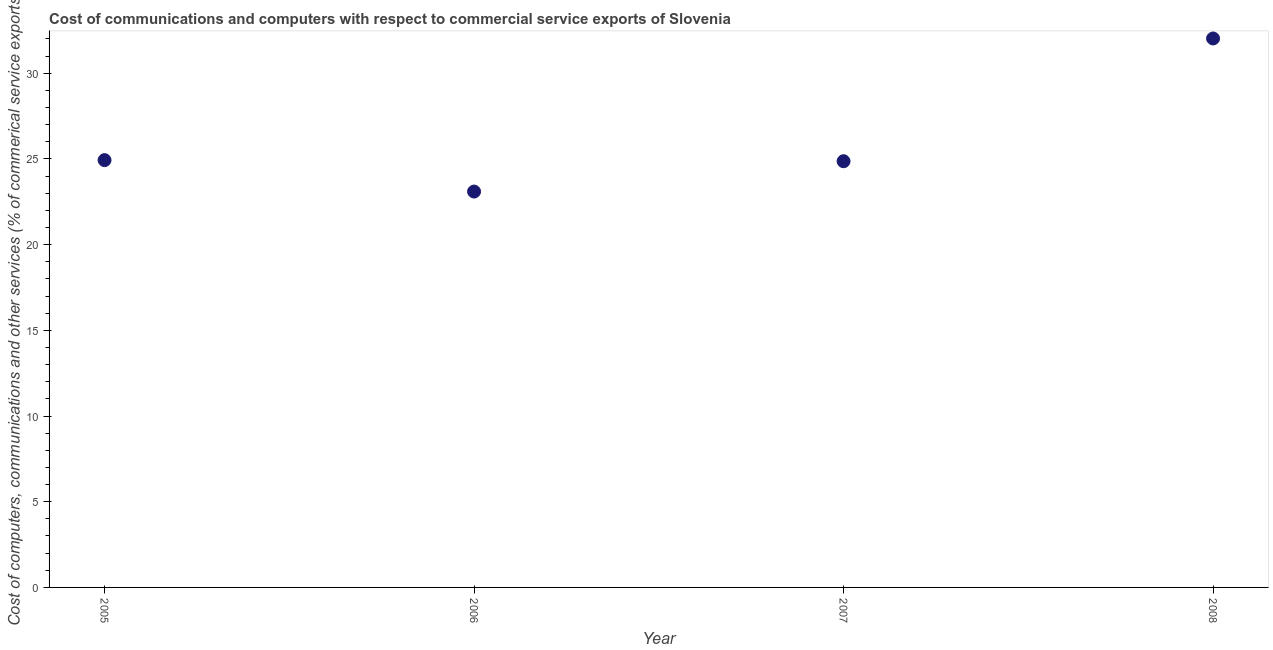What is the  computer and other services in 2006?
Keep it short and to the point. 23.09. Across all years, what is the maximum  computer and other services?
Your response must be concise. 32.02. Across all years, what is the minimum  computer and other services?
Your answer should be compact. 23.09. In which year was the cost of communications maximum?
Keep it short and to the point. 2008. What is the sum of the  computer and other services?
Ensure brevity in your answer.  104.9. What is the difference between the cost of communications in 2006 and 2007?
Give a very brief answer. -1.77. What is the average cost of communications per year?
Your answer should be compact. 26.23. What is the median cost of communications?
Ensure brevity in your answer.  24.89. Do a majority of the years between 2007 and 2008 (inclusive) have cost of communications greater than 29 %?
Keep it short and to the point. No. What is the ratio of the  computer and other services in 2006 to that in 2007?
Your answer should be very brief. 0.93. What is the difference between the highest and the second highest  computer and other services?
Make the answer very short. 7.1. What is the difference between the highest and the lowest cost of communications?
Your answer should be very brief. 8.93. Does the cost of communications monotonically increase over the years?
Offer a terse response. No. Does the graph contain any zero values?
Provide a succinct answer. No. What is the title of the graph?
Your response must be concise. Cost of communications and computers with respect to commercial service exports of Slovenia. What is the label or title of the Y-axis?
Your answer should be compact. Cost of computers, communications and other services (% of commerical service exports). What is the Cost of computers, communications and other services (% of commerical service exports) in 2005?
Offer a very short reply. 24.93. What is the Cost of computers, communications and other services (% of commerical service exports) in 2006?
Ensure brevity in your answer.  23.09. What is the Cost of computers, communications and other services (% of commerical service exports) in 2007?
Make the answer very short. 24.86. What is the Cost of computers, communications and other services (% of commerical service exports) in 2008?
Offer a terse response. 32.02. What is the difference between the Cost of computers, communications and other services (% of commerical service exports) in 2005 and 2006?
Keep it short and to the point. 1.83. What is the difference between the Cost of computers, communications and other services (% of commerical service exports) in 2005 and 2007?
Provide a succinct answer. 0.06. What is the difference between the Cost of computers, communications and other services (% of commerical service exports) in 2005 and 2008?
Your response must be concise. -7.1. What is the difference between the Cost of computers, communications and other services (% of commerical service exports) in 2006 and 2007?
Your answer should be very brief. -1.77. What is the difference between the Cost of computers, communications and other services (% of commerical service exports) in 2006 and 2008?
Your answer should be very brief. -8.93. What is the difference between the Cost of computers, communications and other services (% of commerical service exports) in 2007 and 2008?
Your answer should be very brief. -7.16. What is the ratio of the Cost of computers, communications and other services (% of commerical service exports) in 2005 to that in 2006?
Offer a very short reply. 1.08. What is the ratio of the Cost of computers, communications and other services (% of commerical service exports) in 2005 to that in 2007?
Ensure brevity in your answer.  1. What is the ratio of the Cost of computers, communications and other services (% of commerical service exports) in 2005 to that in 2008?
Provide a short and direct response. 0.78. What is the ratio of the Cost of computers, communications and other services (% of commerical service exports) in 2006 to that in 2007?
Offer a very short reply. 0.93. What is the ratio of the Cost of computers, communications and other services (% of commerical service exports) in 2006 to that in 2008?
Give a very brief answer. 0.72. What is the ratio of the Cost of computers, communications and other services (% of commerical service exports) in 2007 to that in 2008?
Provide a succinct answer. 0.78. 